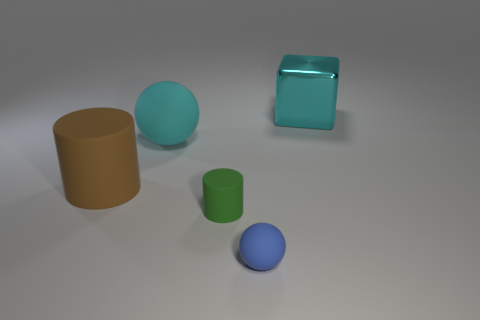There is a matte cylinder that is left of the small rubber cylinder; what size is it?
Your response must be concise. Large. Is the brown matte thing the same size as the cyan metal thing?
Ensure brevity in your answer.  Yes. How many things are either small purple metal spheres or matte balls that are in front of the large sphere?
Provide a succinct answer. 1. What is the material of the cube?
Make the answer very short. Metal. Is there any other thing that has the same color as the small cylinder?
Your answer should be compact. No. Is the shape of the small blue thing the same as the large cyan matte thing?
Provide a succinct answer. Yes. There is a blue object that is in front of the rubber cylinder that is to the right of the sphere behind the big brown rubber object; what is its size?
Ensure brevity in your answer.  Small. How many other objects are the same material as the big cyan ball?
Offer a very short reply. 3. There is a tiny matte thing that is on the right side of the green matte thing; what is its color?
Your answer should be compact. Blue. What material is the big cyan thing right of the cylinder right of the cyan thing that is in front of the big shiny cube?
Offer a terse response. Metal. 